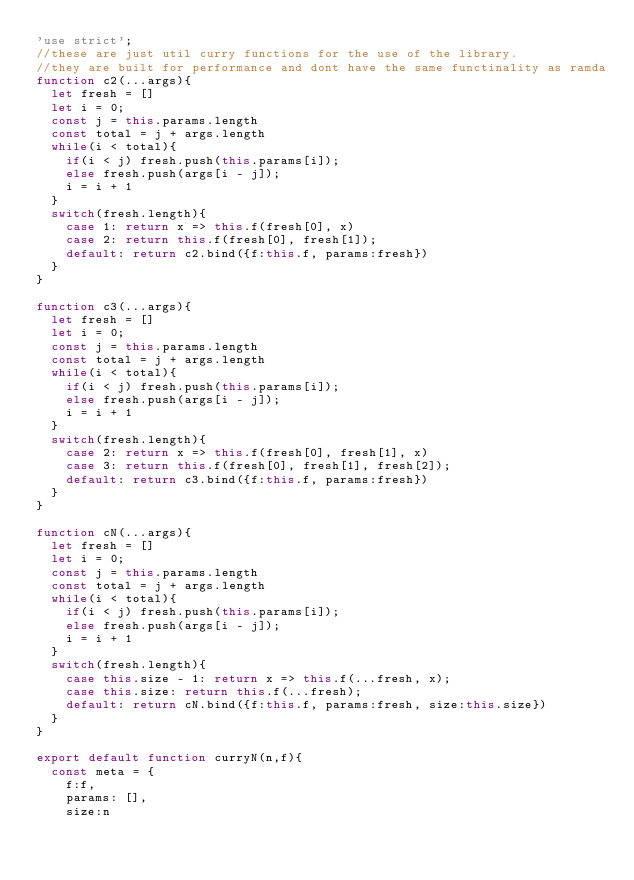Convert code to text. <code><loc_0><loc_0><loc_500><loc_500><_JavaScript_>'use strict';
//these are just util curry functions for the use of the library.
//they are built for performance and dont have the same functinality as ramda
function c2(...args){
  let fresh = []
  let i = 0;
  const j = this.params.length
  const total = j + args.length
  while(i < total){
    if(i < j) fresh.push(this.params[i]);
    else fresh.push(args[i - j]);
    i = i + 1
  }
  switch(fresh.length){
    case 1: return x => this.f(fresh[0], x)
    case 2: return this.f(fresh[0], fresh[1]);
    default: return c2.bind({f:this.f, params:fresh}) 
  }
}

function c3(...args){
  let fresh = []
  let i = 0;
  const j = this.params.length
  const total = j + args.length
  while(i < total){
    if(i < j) fresh.push(this.params[i]);
    else fresh.push(args[i - j]);
    i = i + 1
  }
  switch(fresh.length){
    case 2: return x => this.f(fresh[0], fresh[1], x)
    case 3: return this.f(fresh[0], fresh[1], fresh[2]);
    default: return c3.bind({f:this.f, params:fresh}) 
  }
}

function cN(...args){
  let fresh = []
  let i = 0;
  const j = this.params.length
  const total = j + args.length
  while(i < total){
    if(i < j) fresh.push(this.params[i]);
    else fresh.push(args[i - j]);
    i = i + 1
  }
  switch(fresh.length){
    case this.size - 1: return x => this.f(...fresh, x);
    case this.size: return this.f(...fresh);
    default: return cN.bind({f:this.f, params:fresh, size:this.size}) 
  }
}

export default function curryN(n,f){
  const meta = {
    f:f,
    params: [],
    size:n</code> 